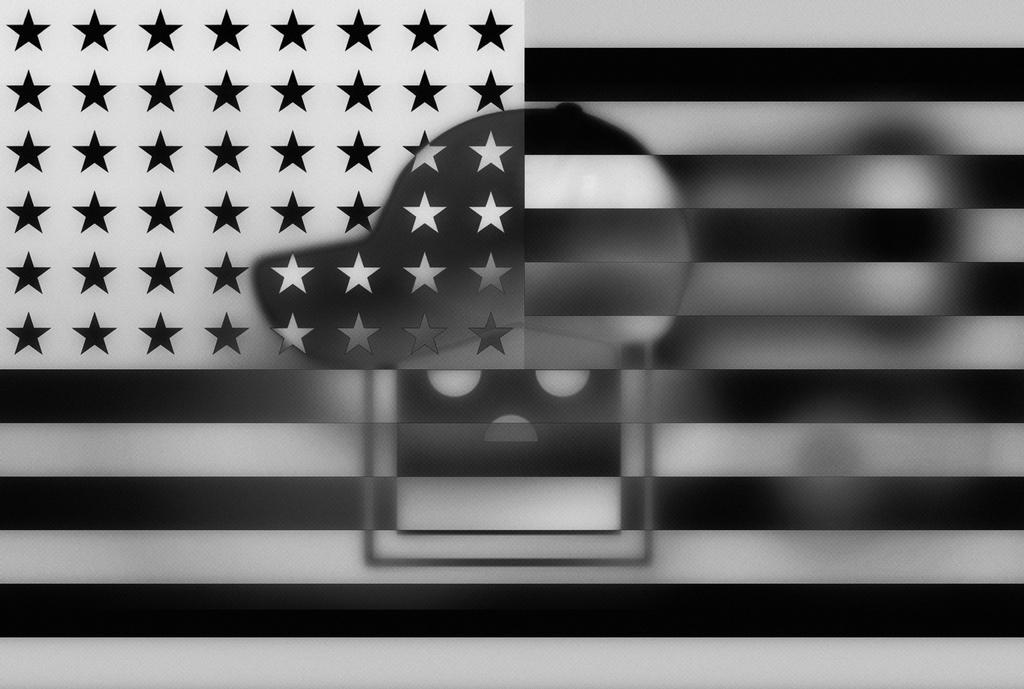Describe this image in one or two sentences. In this image there is a flag and in the center there is a cap. 